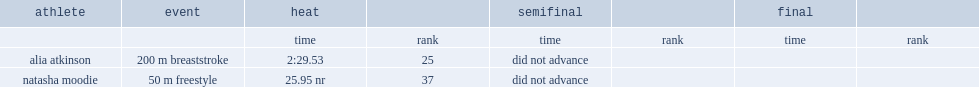In heat, what is the result for natasha moodie finishing the race? 25.95 nr. 